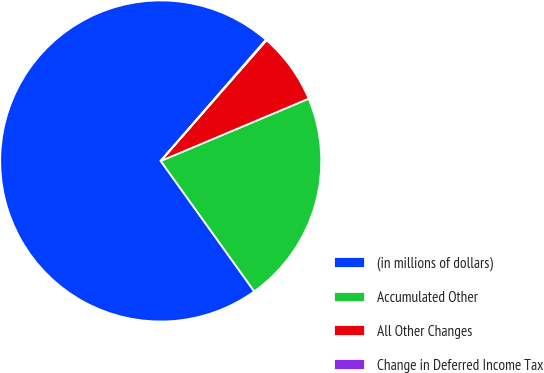Convert chart to OTSL. <chart><loc_0><loc_0><loc_500><loc_500><pie_chart><fcel>(in millions of dollars)<fcel>Accumulated Other<fcel>All Other Changes<fcel>Change in Deferred Income Tax<nl><fcel>71.28%<fcel>21.44%<fcel>7.2%<fcel>0.08%<nl></chart> 